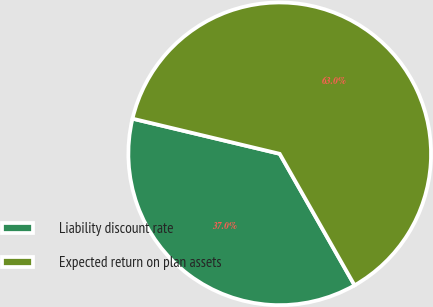<chart> <loc_0><loc_0><loc_500><loc_500><pie_chart><fcel>Liability discount rate<fcel>Expected return on plan assets<nl><fcel>36.97%<fcel>63.03%<nl></chart> 